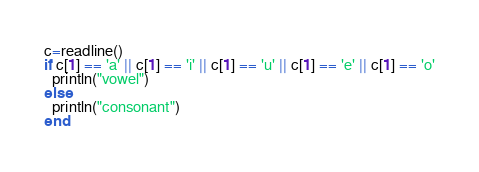<code> <loc_0><loc_0><loc_500><loc_500><_Julia_>c=readline()
if c[1] == 'a' || c[1] == 'i' || c[1] == 'u' || c[1] == 'e' || c[1] == 'o'
  println("vowel")
else
  println("consonant")
end
</code> 